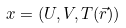<formula> <loc_0><loc_0><loc_500><loc_500>x = ( U , V , T ( \vec { r } ) )</formula> 